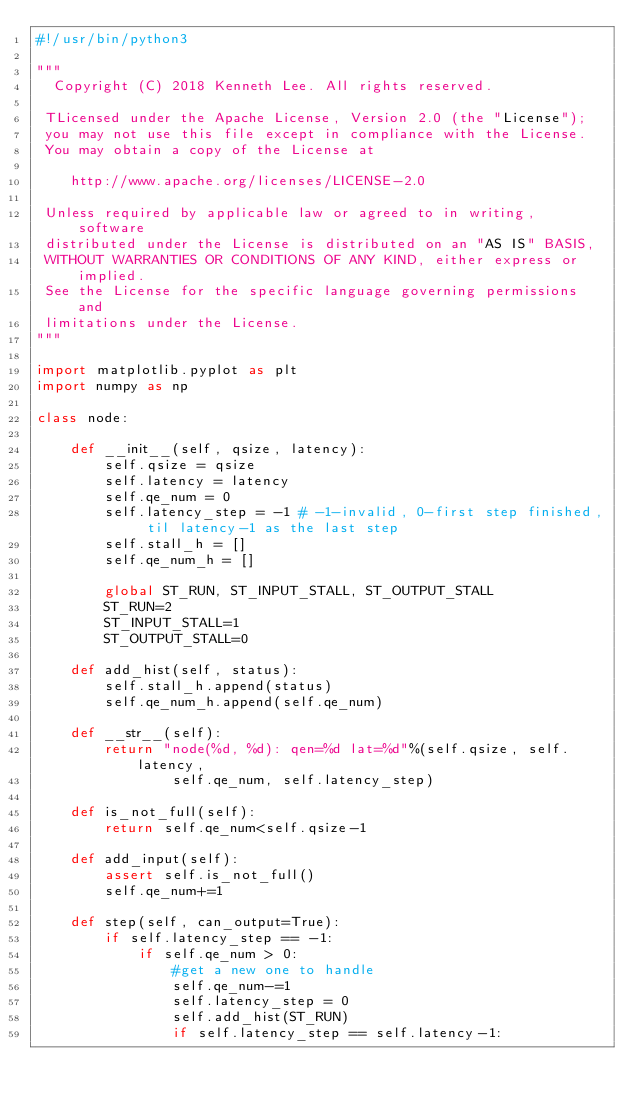Convert code to text. <code><loc_0><loc_0><loc_500><loc_500><_Python_>#!/usr/bin/python3

"""
  Copyright (C) 2018 Kenneth Lee. All rights reserved.

 TLicensed under the Apache License, Version 2.0 (the "License");
 you may not use this file except in compliance with the License.
 You may obtain a copy of the License at

    http://www.apache.org/licenses/LICENSE-2.0

 Unless required by applicable law or agreed to in writing, software
 distributed under the License is distributed on an "AS IS" BASIS,
 WITHOUT WARRANTIES OR CONDITIONS OF ANY KIND, either express or implied.
 See the License for the specific language governing permissions and
 limitations under the License.
"""

import matplotlib.pyplot as plt
import numpy as np

class node:

    def __init__(self, qsize, latency):
        self.qsize = qsize
        self.latency = latency
        self.qe_num = 0
        self.latency_step = -1 # -1-invalid, 0-first step finished, til latency-1 as the last step
        self.stall_h = []
        self.qe_num_h = []

        global ST_RUN, ST_INPUT_STALL, ST_OUTPUT_STALL
        ST_RUN=2
        ST_INPUT_STALL=1
        ST_OUTPUT_STALL=0

    def add_hist(self, status):
        self.stall_h.append(status)
        self.qe_num_h.append(self.qe_num)

    def __str__(self):
        return "node(%d, %d): qen=%d lat=%d"%(self.qsize, self.latency,
                self.qe_num, self.latency_step)

    def is_not_full(self):
        return self.qe_num<self.qsize-1

    def add_input(self):
        assert self.is_not_full()
        self.qe_num+=1

    def step(self, can_output=True):
        if self.latency_step == -1:
            if self.qe_num > 0:
                #get a new one to handle
                self.qe_num-=1
                self.latency_step = 0
                self.add_hist(ST_RUN)
                if self.latency_step == self.latency-1:</code> 